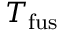Convert formula to latex. <formula><loc_0><loc_0><loc_500><loc_500>T _ { f u s }</formula> 